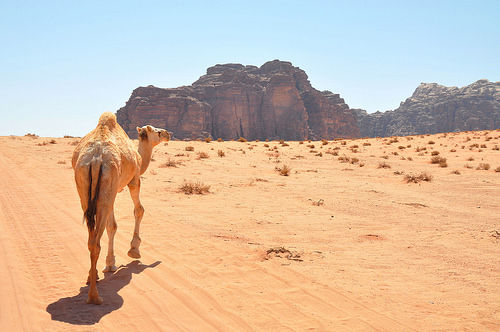<image>
Is the mountain behind the camel? No. The mountain is not behind the camel. From this viewpoint, the mountain appears to be positioned elsewhere in the scene. 